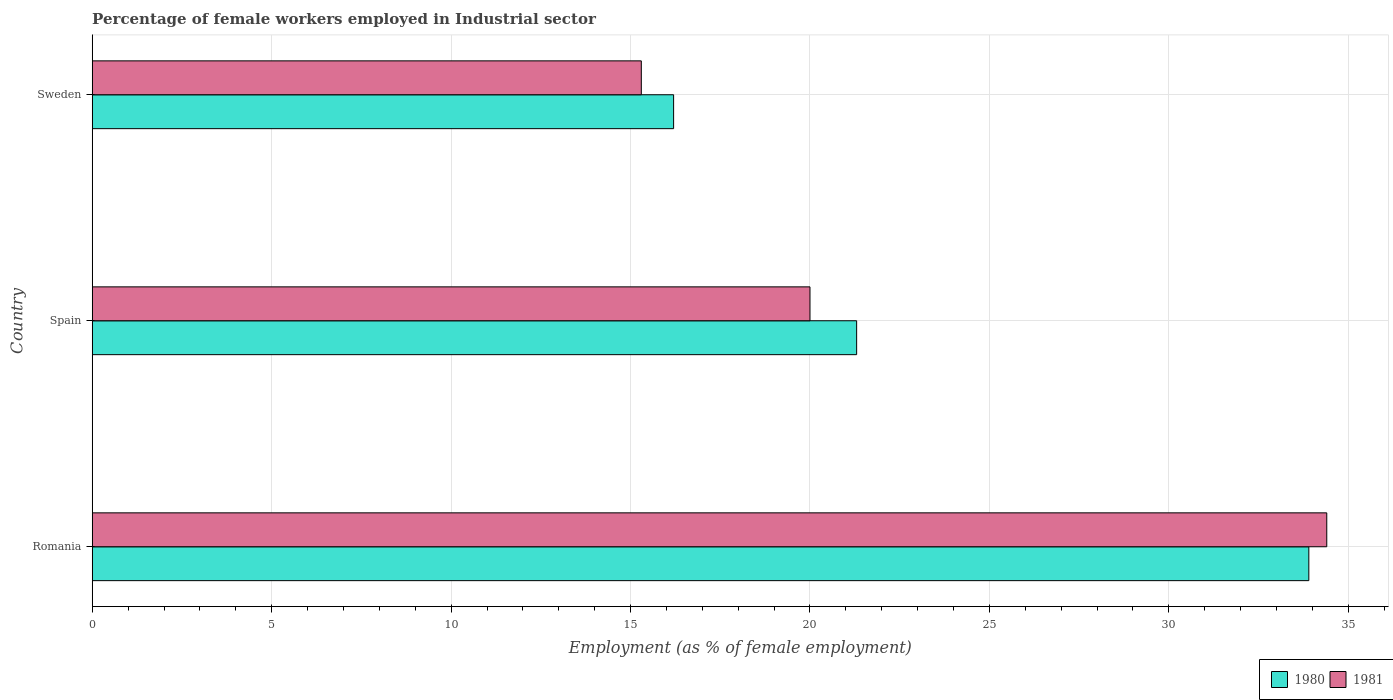How many groups of bars are there?
Offer a terse response. 3. What is the label of the 3rd group of bars from the top?
Ensure brevity in your answer.  Romania. Across all countries, what is the maximum percentage of females employed in Industrial sector in 1981?
Your response must be concise. 34.4. Across all countries, what is the minimum percentage of females employed in Industrial sector in 1981?
Your answer should be compact. 15.3. In which country was the percentage of females employed in Industrial sector in 1980 maximum?
Make the answer very short. Romania. What is the total percentage of females employed in Industrial sector in 1981 in the graph?
Your answer should be compact. 69.7. What is the difference between the percentage of females employed in Industrial sector in 1981 in Spain and that in Sweden?
Give a very brief answer. 4.7. What is the difference between the percentage of females employed in Industrial sector in 1980 in Romania and the percentage of females employed in Industrial sector in 1981 in Sweden?
Make the answer very short. 18.6. What is the average percentage of females employed in Industrial sector in 1981 per country?
Give a very brief answer. 23.23. What is the difference between the percentage of females employed in Industrial sector in 1980 and percentage of females employed in Industrial sector in 1981 in Romania?
Offer a very short reply. -0.5. What is the ratio of the percentage of females employed in Industrial sector in 1981 in Romania to that in Spain?
Offer a terse response. 1.72. Is the percentage of females employed in Industrial sector in 1980 in Spain less than that in Sweden?
Offer a very short reply. No. What is the difference between the highest and the second highest percentage of females employed in Industrial sector in 1981?
Ensure brevity in your answer.  14.4. What is the difference between the highest and the lowest percentage of females employed in Industrial sector in 1980?
Your answer should be compact. 17.7. In how many countries, is the percentage of females employed in Industrial sector in 1981 greater than the average percentage of females employed in Industrial sector in 1981 taken over all countries?
Offer a terse response. 1. Is the sum of the percentage of females employed in Industrial sector in 1981 in Romania and Spain greater than the maximum percentage of females employed in Industrial sector in 1980 across all countries?
Offer a terse response. Yes. What does the 1st bar from the top in Spain represents?
Make the answer very short. 1981. What does the 1st bar from the bottom in Spain represents?
Offer a terse response. 1980. Are all the bars in the graph horizontal?
Give a very brief answer. Yes. How many countries are there in the graph?
Give a very brief answer. 3. Are the values on the major ticks of X-axis written in scientific E-notation?
Your response must be concise. No. How are the legend labels stacked?
Make the answer very short. Horizontal. What is the title of the graph?
Your answer should be very brief. Percentage of female workers employed in Industrial sector. What is the label or title of the X-axis?
Provide a succinct answer. Employment (as % of female employment). What is the label or title of the Y-axis?
Provide a short and direct response. Country. What is the Employment (as % of female employment) of 1980 in Romania?
Your response must be concise. 33.9. What is the Employment (as % of female employment) in 1981 in Romania?
Your answer should be compact. 34.4. What is the Employment (as % of female employment) of 1980 in Spain?
Your answer should be compact. 21.3. What is the Employment (as % of female employment) of 1980 in Sweden?
Provide a short and direct response. 16.2. What is the Employment (as % of female employment) of 1981 in Sweden?
Offer a very short reply. 15.3. Across all countries, what is the maximum Employment (as % of female employment) of 1980?
Make the answer very short. 33.9. Across all countries, what is the maximum Employment (as % of female employment) of 1981?
Provide a short and direct response. 34.4. Across all countries, what is the minimum Employment (as % of female employment) of 1980?
Your answer should be compact. 16.2. Across all countries, what is the minimum Employment (as % of female employment) in 1981?
Provide a succinct answer. 15.3. What is the total Employment (as % of female employment) in 1980 in the graph?
Your answer should be very brief. 71.4. What is the total Employment (as % of female employment) in 1981 in the graph?
Keep it short and to the point. 69.7. What is the difference between the Employment (as % of female employment) of 1980 in Spain and that in Sweden?
Keep it short and to the point. 5.1. What is the difference between the Employment (as % of female employment) in 1980 in Romania and the Employment (as % of female employment) in 1981 in Spain?
Your answer should be compact. 13.9. What is the difference between the Employment (as % of female employment) of 1980 in Spain and the Employment (as % of female employment) of 1981 in Sweden?
Give a very brief answer. 6. What is the average Employment (as % of female employment) in 1980 per country?
Your answer should be compact. 23.8. What is the average Employment (as % of female employment) in 1981 per country?
Give a very brief answer. 23.23. What is the difference between the Employment (as % of female employment) in 1980 and Employment (as % of female employment) in 1981 in Romania?
Ensure brevity in your answer.  -0.5. What is the difference between the Employment (as % of female employment) of 1980 and Employment (as % of female employment) of 1981 in Spain?
Your answer should be very brief. 1.3. What is the ratio of the Employment (as % of female employment) in 1980 in Romania to that in Spain?
Provide a short and direct response. 1.59. What is the ratio of the Employment (as % of female employment) in 1981 in Romania to that in Spain?
Offer a very short reply. 1.72. What is the ratio of the Employment (as % of female employment) of 1980 in Romania to that in Sweden?
Provide a short and direct response. 2.09. What is the ratio of the Employment (as % of female employment) of 1981 in Romania to that in Sweden?
Give a very brief answer. 2.25. What is the ratio of the Employment (as % of female employment) in 1980 in Spain to that in Sweden?
Offer a very short reply. 1.31. What is the ratio of the Employment (as % of female employment) of 1981 in Spain to that in Sweden?
Provide a succinct answer. 1.31. What is the difference between the highest and the second highest Employment (as % of female employment) in 1980?
Your response must be concise. 12.6. What is the difference between the highest and the second highest Employment (as % of female employment) of 1981?
Provide a short and direct response. 14.4. What is the difference between the highest and the lowest Employment (as % of female employment) in 1980?
Offer a very short reply. 17.7. 